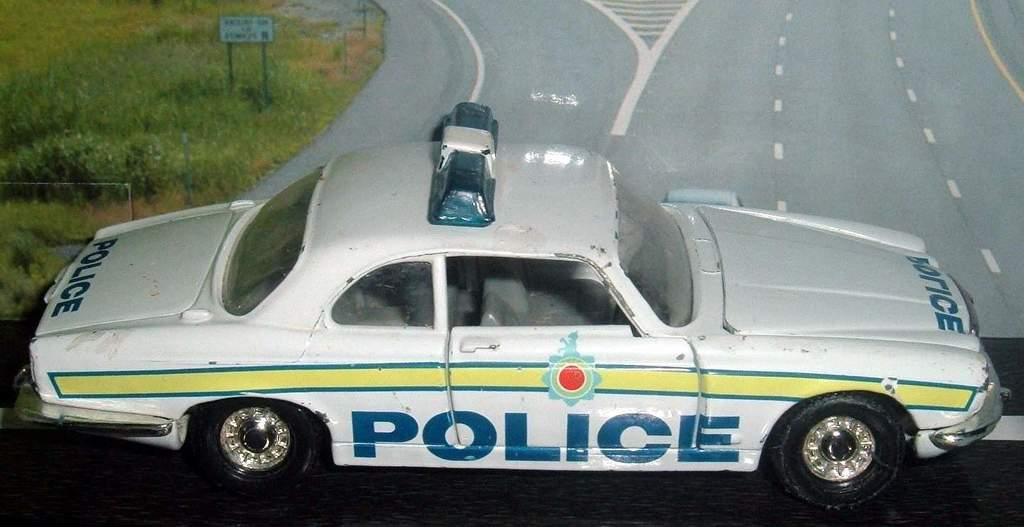What type of toy is present in the image? There is a toy vehicle in the image. What is visible behind the toy vehicle? There is a road and grass behind the vehicle. What other objects can be seen in the image? There are sign boards in the image. Can you hear the cow mooing in the image? There is no cow present in the image, so it is not possible to hear a cow mooing. 